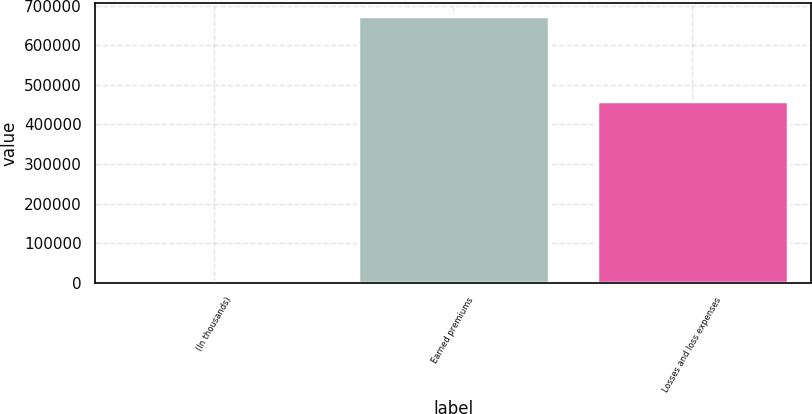Convert chart to OTSL. <chart><loc_0><loc_0><loc_500><loc_500><bar_chart><fcel>(In thousands)<fcel>Earned premiums<fcel>Losses and loss expenses<nl><fcel>2011<fcel>673003<fcel>458249<nl></chart> 